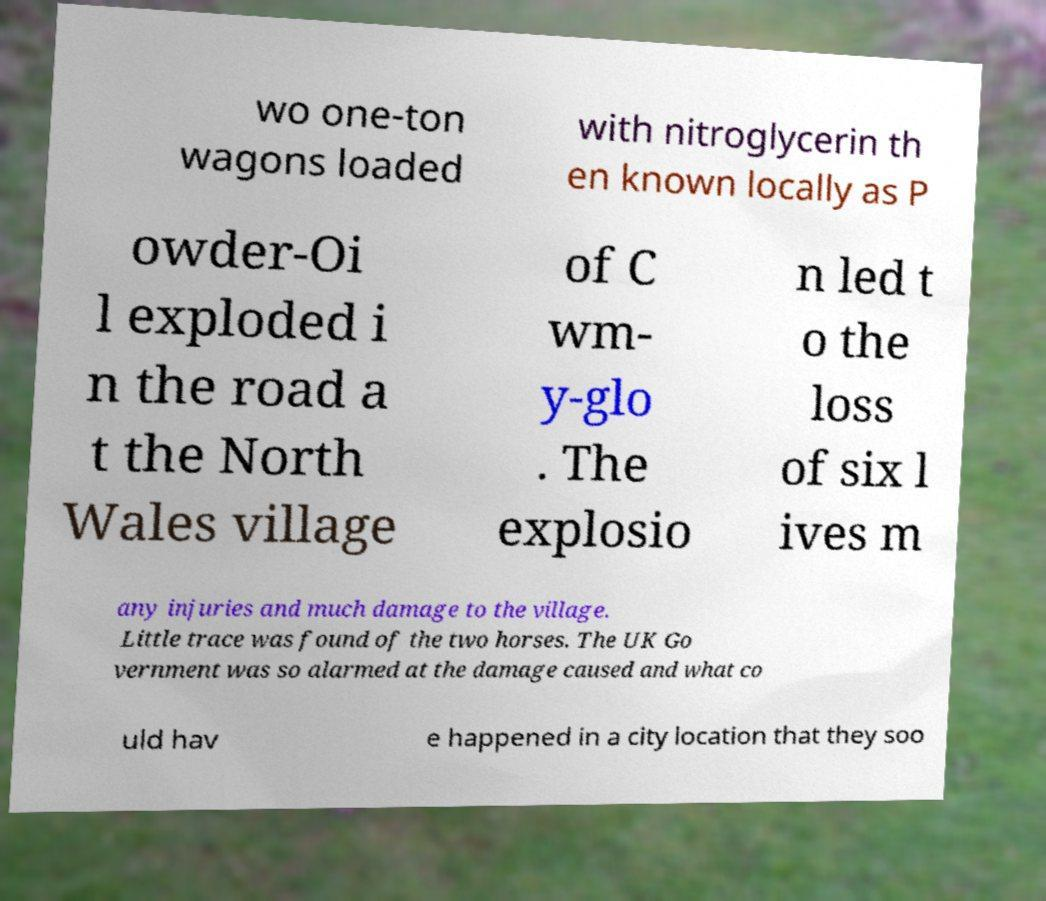Could you extract and type out the text from this image? wo one-ton wagons loaded with nitroglycerin th en known locally as P owder-Oi l exploded i n the road a t the North Wales village of C wm- y-glo . The explosio n led t o the loss of six l ives m any injuries and much damage to the village. Little trace was found of the two horses. The UK Go vernment was so alarmed at the damage caused and what co uld hav e happened in a city location that they soo 